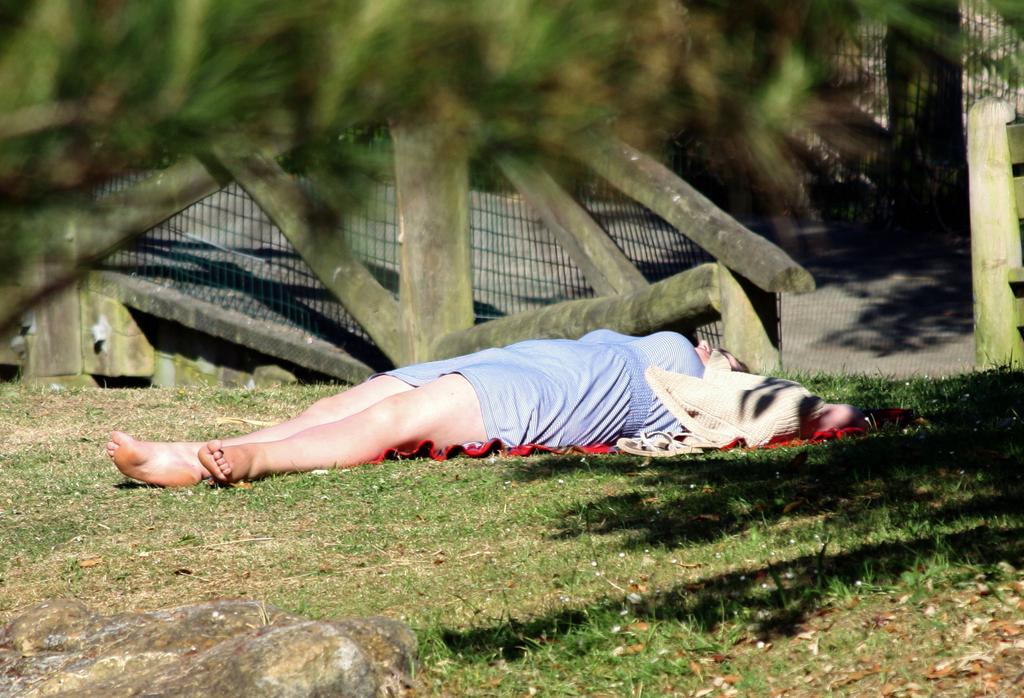In one or two sentences, can you explain what this image depicts? In this image there is one person is lying on the surface as we can see in middle of this image is an wooden object is at top of this image and there are some stones at bottom of this image and there are some grass in the background. 